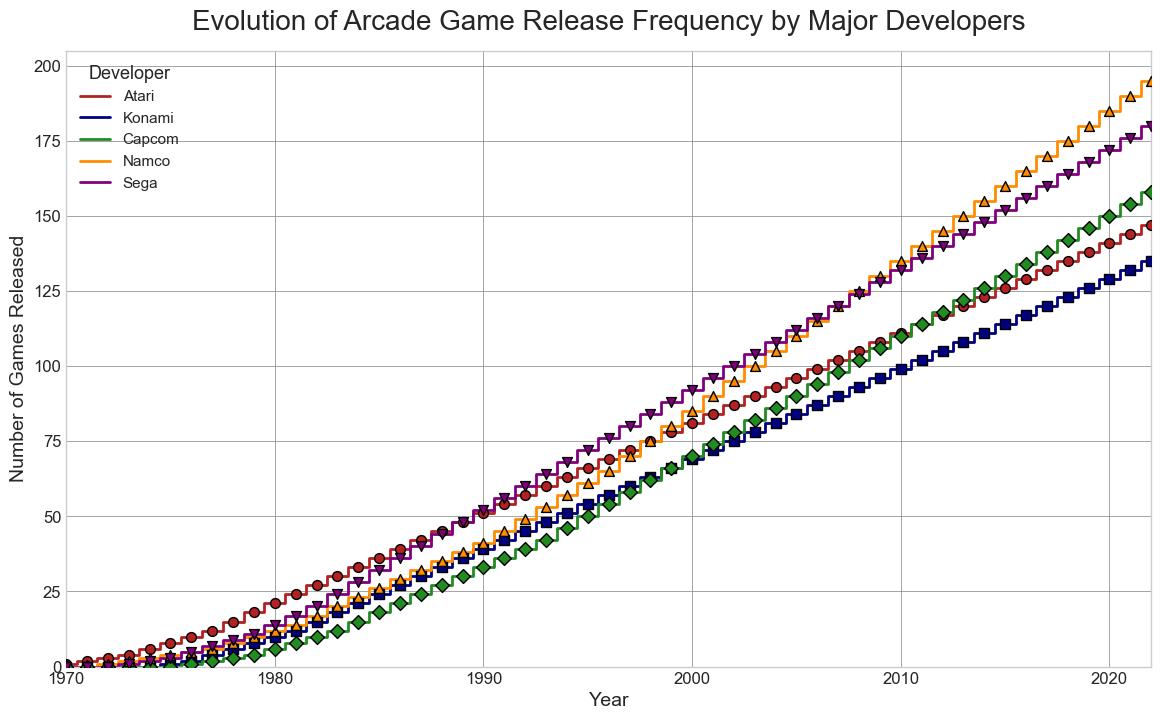Which developer released the most games in 1983? To find which developer released the most games in 1983, locate the year 1983 on the x-axis and compare the points on the y-axis for each developer. Namco has the highest point at 20 games.
Answer: Namco How many more games did Sega release in 1987 than in 1982? To determine how many more games Sega released in 1987 than in 1982, locate the points for Sega in 1987 and 1982 on the y-axis. In 1987, Sega released 40 games, and in 1982, it released 20 games. The difference is 40 - 20 = 20 games.
Answer: 20 Which two developers had almost identical number of game releases around the year 1976? To identify the developers with nearly identical releases around 1976, look at the points at 1976 on the x-axis. Atari released 10 games, Konami released 2, Capcom released 1, Namco released 5, and Sega released 5. Namco and Sega have nearly identical releases with 5 each.
Answer: Namco and Sega Between 1990 and 1995, which developer showed the greatest increase in game releases? To determine which developer showed the greatest increase in game releases between 1990 and 1995, observe the y-axis values for each developer at 1990 and 1995, then calculate the differences: Atari (66-51=15), Konami (54-39=15), Capcom (50-33=17), Namco (61-41=20), Sega (72-52=20). Namco and Sega both increased their releases by 20.
Answer: Namco and Sega What is the total number of games released by all developers in the year 2000? To find the total number of games released by all developers in 2000, locate the y-axis values for each developer at 2000 and sum them up: Atari (81), Konami (69), Capcom (70), Namco (85), Sega (92). The total is 81 + 69 + 70 + 85 + 92 = 397.
Answer: 397 Which developer had the steepest increase in game releases in the first 10 years displayed? To determine the developer with the steepest increase in the first 10 years (1970-1980), observe the y-axis values for each developer at 1970 and 1980, then calculate the differences: Atari (21-1=20), Konami (10-0=10), Capcom (6-0=6), Namco (12-1=11), Sega (14-0=14). Atari increased the most by 20 games.
Answer: Atari How does the release frequency of Namco change from 2005 to 2015? To observe Namco's release frequency change from 2005 to 2015, look at the y-axis values for Namco in 2005 and 2015. In 2005, Namco released 110 games, and in 2015, 160 games. The change is 160 - 110 = 50 games.
Answer: Increased by 50 games Comparing Atari and Capcom, which developer had more gradual changes in their game release frequency? To compare the trends, observe the steepness of the step plots for Atari and Capcom. Atari's releases increase steadily and notably over most years, while Capcom's releases are more gradual and less steep, indicating gentler changes.
Answer: Capcom 